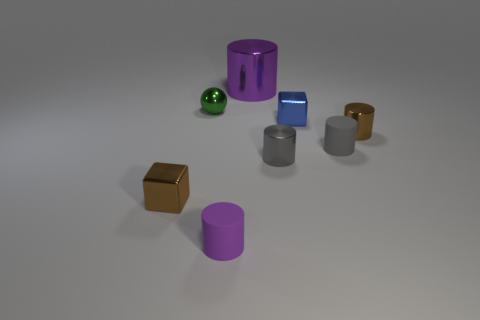Subtract all brown cylinders. How many cylinders are left? 4 Subtract all brown cylinders. How many cylinders are left? 4 Subtract all cyan cylinders. Subtract all cyan balls. How many cylinders are left? 5 Add 1 gray shiny cylinders. How many objects exist? 9 Subtract all cubes. How many objects are left? 6 Add 4 tiny cylinders. How many tiny cylinders are left? 8 Add 8 green balls. How many green balls exist? 9 Subtract 0 green cubes. How many objects are left? 8 Subtract all tiny blue metal things. Subtract all purple things. How many objects are left? 5 